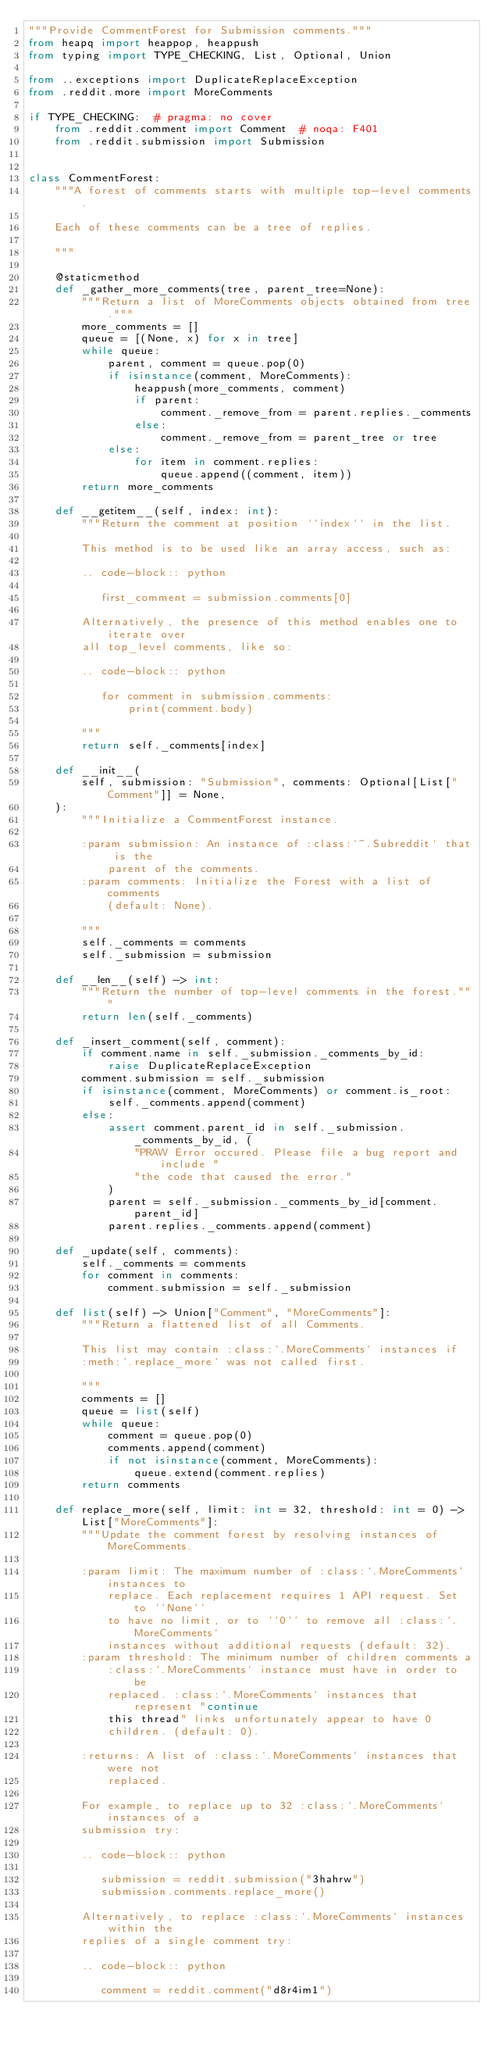Convert code to text. <code><loc_0><loc_0><loc_500><loc_500><_Python_>"""Provide CommentForest for Submission comments."""
from heapq import heappop, heappush
from typing import TYPE_CHECKING, List, Optional, Union

from ..exceptions import DuplicateReplaceException
from .reddit.more import MoreComments

if TYPE_CHECKING:  # pragma: no cover
    from .reddit.comment import Comment  # noqa: F401
    from .reddit.submission import Submission


class CommentForest:
    """A forest of comments starts with multiple top-level comments.

    Each of these comments can be a tree of replies.

    """

    @staticmethod
    def _gather_more_comments(tree, parent_tree=None):
        """Return a list of MoreComments objects obtained from tree."""
        more_comments = []
        queue = [(None, x) for x in tree]
        while queue:
            parent, comment = queue.pop(0)
            if isinstance(comment, MoreComments):
                heappush(more_comments, comment)
                if parent:
                    comment._remove_from = parent.replies._comments
                else:
                    comment._remove_from = parent_tree or tree
            else:
                for item in comment.replies:
                    queue.append((comment, item))
        return more_comments

    def __getitem__(self, index: int):
        """Return the comment at position ``index`` in the list.

        This method is to be used like an array access, such as:

        .. code-block:: python

           first_comment = submission.comments[0]

        Alternatively, the presence of this method enables one to iterate over
        all top_level comments, like so:

        .. code-block:: python

           for comment in submission.comments:
               print(comment.body)

        """
        return self._comments[index]

    def __init__(
        self, submission: "Submission", comments: Optional[List["Comment"]] = None,
    ):
        """Initialize a CommentForest instance.

        :param submission: An instance of :class:`~.Subreddit` that is the
            parent of the comments.
        :param comments: Initialize the Forest with a list of comments
            (default: None).

        """
        self._comments = comments
        self._submission = submission

    def __len__(self) -> int:
        """Return the number of top-level comments in the forest."""
        return len(self._comments)

    def _insert_comment(self, comment):
        if comment.name in self._submission._comments_by_id:
            raise DuplicateReplaceException
        comment.submission = self._submission
        if isinstance(comment, MoreComments) or comment.is_root:
            self._comments.append(comment)
        else:
            assert comment.parent_id in self._submission._comments_by_id, (
                "PRAW Error occured. Please file a bug report and include "
                "the code that caused the error."
            )
            parent = self._submission._comments_by_id[comment.parent_id]
            parent.replies._comments.append(comment)

    def _update(self, comments):
        self._comments = comments
        for comment in comments:
            comment.submission = self._submission

    def list(self) -> Union["Comment", "MoreComments"]:
        """Return a flattened list of all Comments.

        This list may contain :class:`.MoreComments` instances if
        :meth:`.replace_more` was not called first.

        """
        comments = []
        queue = list(self)
        while queue:
            comment = queue.pop(0)
            comments.append(comment)
            if not isinstance(comment, MoreComments):
                queue.extend(comment.replies)
        return comments

    def replace_more(self, limit: int = 32, threshold: int = 0) -> List["MoreComments"]:
        """Update the comment forest by resolving instances of MoreComments.

        :param limit: The maximum number of :class:`.MoreComments` instances to
            replace. Each replacement requires 1 API request. Set to ``None``
            to have no limit, or to ``0`` to remove all :class:`.MoreComments`
            instances without additional requests (default: 32).
        :param threshold: The minimum number of children comments a
            :class:`.MoreComments` instance must have in order to be
            replaced. :class:`.MoreComments` instances that represent "continue
            this thread" links unfortunately appear to have 0
            children. (default: 0).

        :returns: A list of :class:`.MoreComments` instances that were not
            replaced.

        For example, to replace up to 32 :class:`.MoreComments` instances of a
        submission try:

        .. code-block:: python

           submission = reddit.submission("3hahrw")
           submission.comments.replace_more()

        Alternatively, to replace :class:`.MoreComments` instances within the
        replies of a single comment try:

        .. code-block:: python

           comment = reddit.comment("d8r4im1")</code> 